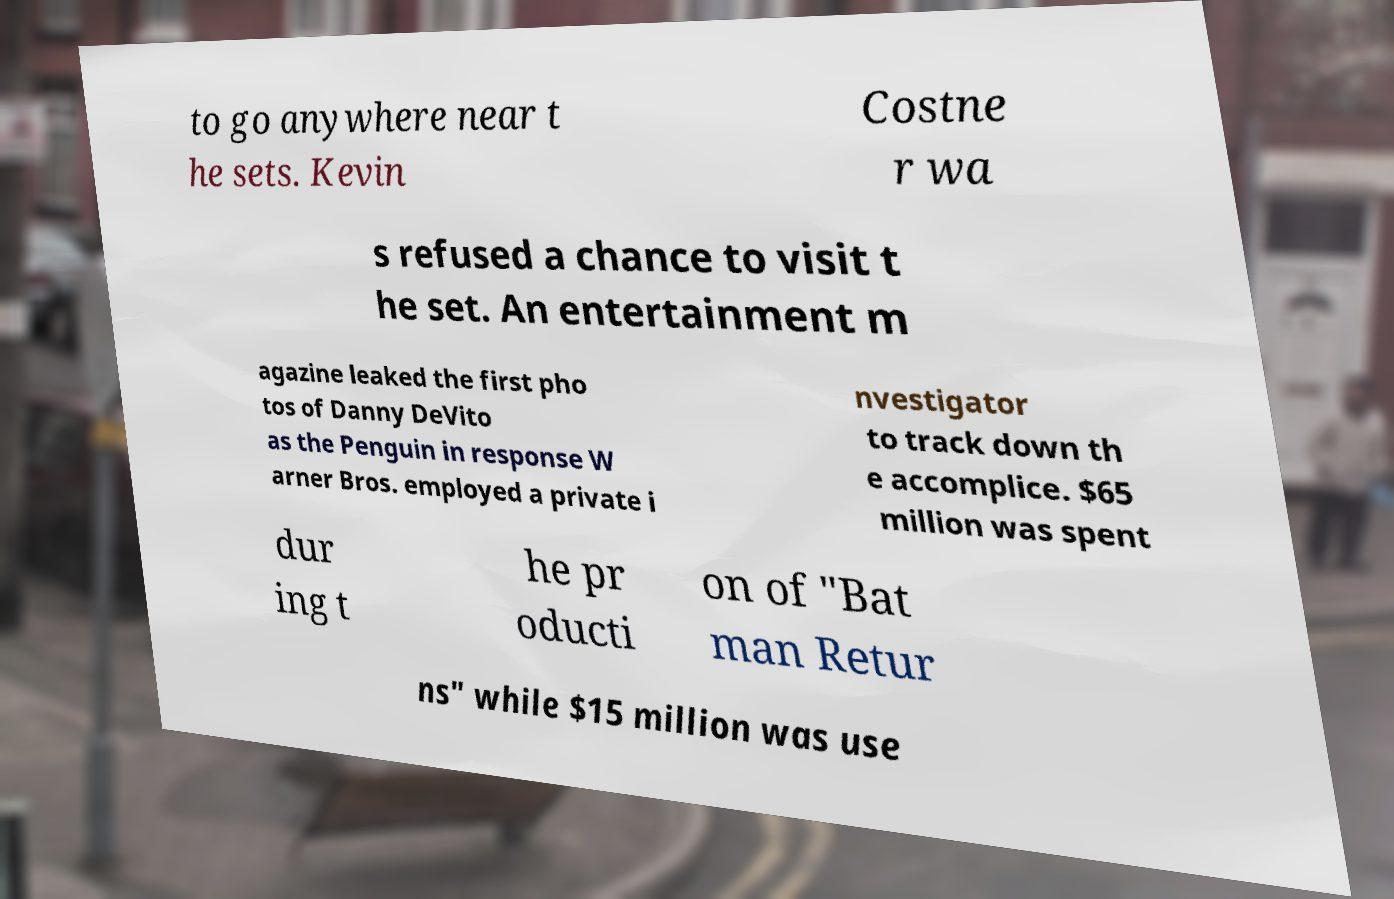Could you assist in decoding the text presented in this image and type it out clearly? to go anywhere near t he sets. Kevin Costne r wa s refused a chance to visit t he set. An entertainment m agazine leaked the first pho tos of Danny DeVito as the Penguin in response W arner Bros. employed a private i nvestigator to track down th e accomplice. $65 million was spent dur ing t he pr oducti on of "Bat man Retur ns" while $15 million was use 